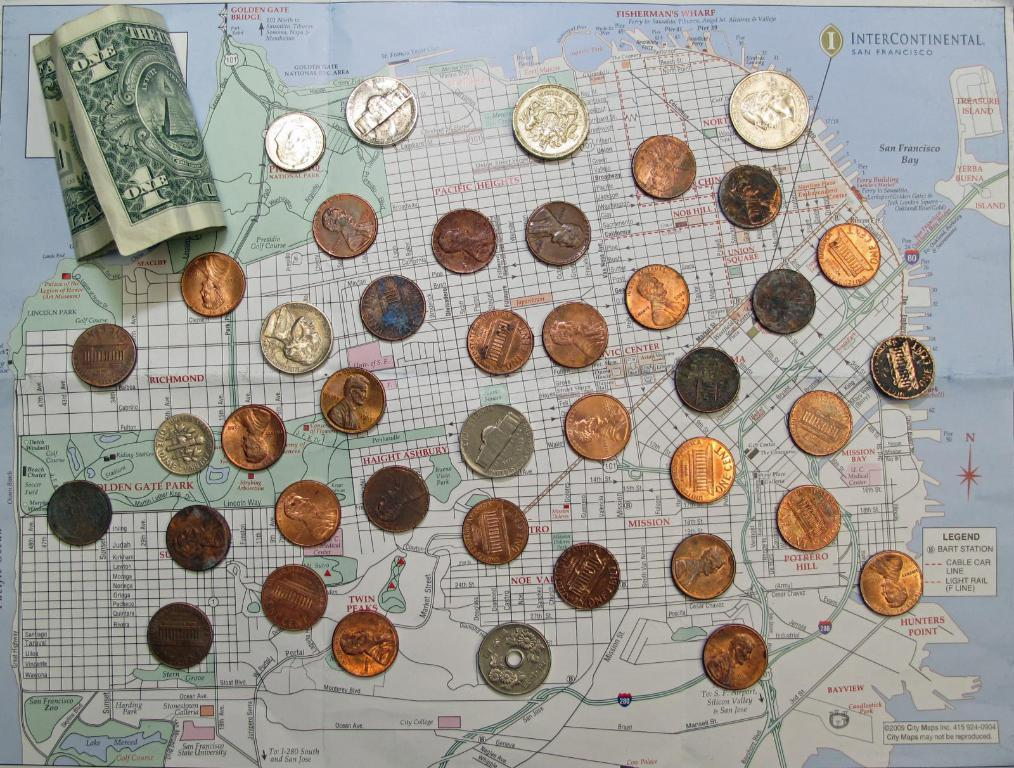Provide a one-sentence caption for the provided image. A dollar bill and a bunch of coins are spread out on top of a San Francisco area map. 